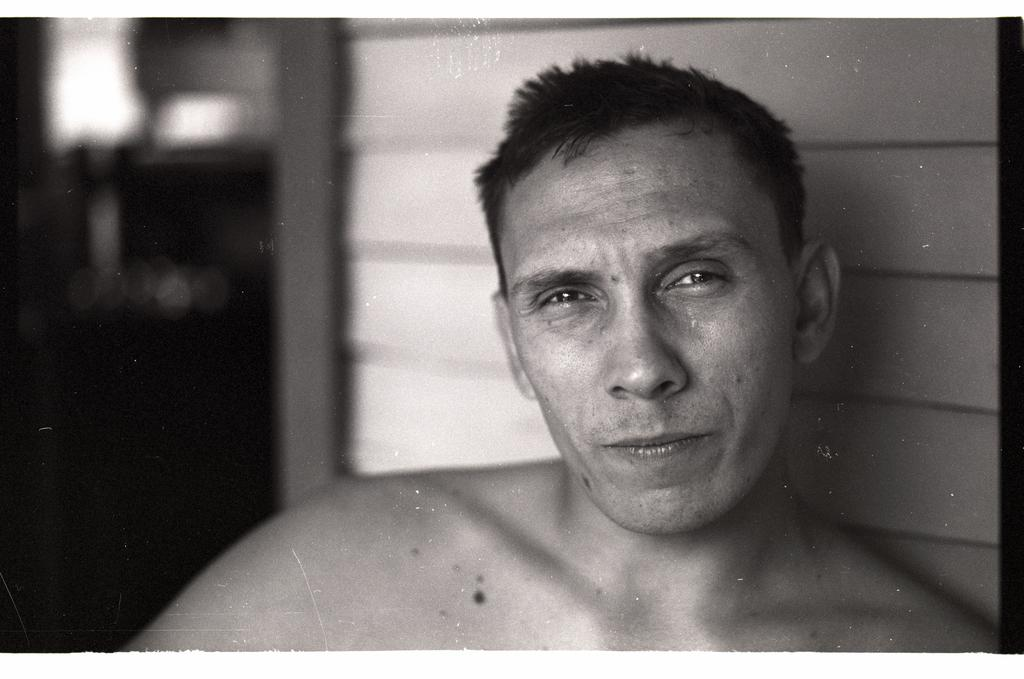What is the appearance of the person on the right side of the image? The person is without a shirt. What is the person doing in the image? The person is watching something. Can you describe the background of the image? The background of the image is blurred. How many minutes does it take for the sun to appear in the image? There is no sun present in the image, so it cannot be determined how long it would take for the sun to appear. 